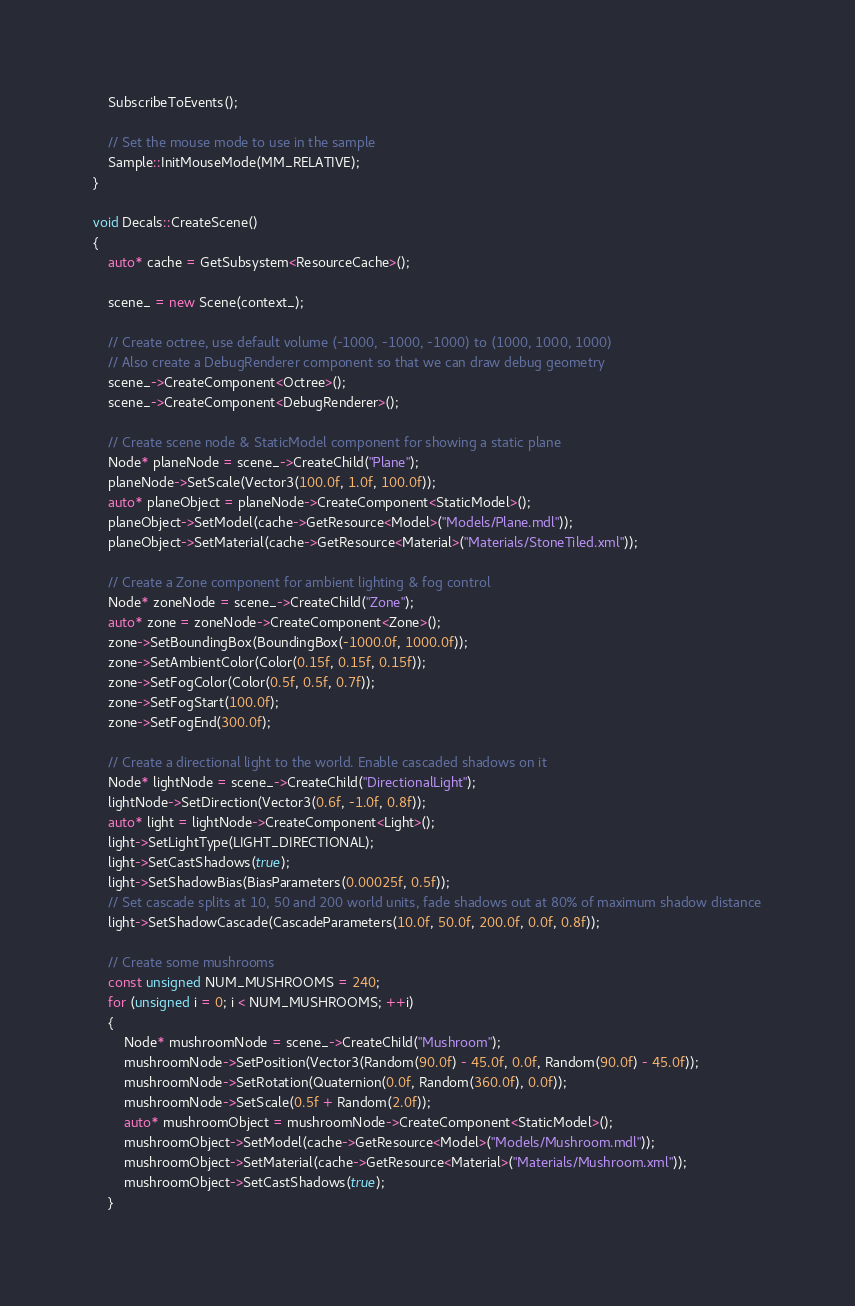Convert code to text. <code><loc_0><loc_0><loc_500><loc_500><_C++_>    SubscribeToEvents();

    // Set the mouse mode to use in the sample
    Sample::InitMouseMode(MM_RELATIVE);
}

void Decals::CreateScene()
{
    auto* cache = GetSubsystem<ResourceCache>();

    scene_ = new Scene(context_);

    // Create octree, use default volume (-1000, -1000, -1000) to (1000, 1000, 1000)
    // Also create a DebugRenderer component so that we can draw debug geometry
    scene_->CreateComponent<Octree>();
    scene_->CreateComponent<DebugRenderer>();

    // Create scene node & StaticModel component for showing a static plane
    Node* planeNode = scene_->CreateChild("Plane");
    planeNode->SetScale(Vector3(100.0f, 1.0f, 100.0f));
    auto* planeObject = planeNode->CreateComponent<StaticModel>();
    planeObject->SetModel(cache->GetResource<Model>("Models/Plane.mdl"));
    planeObject->SetMaterial(cache->GetResource<Material>("Materials/StoneTiled.xml"));

    // Create a Zone component for ambient lighting & fog control
    Node* zoneNode = scene_->CreateChild("Zone");
    auto* zone = zoneNode->CreateComponent<Zone>();
    zone->SetBoundingBox(BoundingBox(-1000.0f, 1000.0f));
    zone->SetAmbientColor(Color(0.15f, 0.15f, 0.15f));
    zone->SetFogColor(Color(0.5f, 0.5f, 0.7f));
    zone->SetFogStart(100.0f);
    zone->SetFogEnd(300.0f);

    // Create a directional light to the world. Enable cascaded shadows on it
    Node* lightNode = scene_->CreateChild("DirectionalLight");
    lightNode->SetDirection(Vector3(0.6f, -1.0f, 0.8f));
    auto* light = lightNode->CreateComponent<Light>();
    light->SetLightType(LIGHT_DIRECTIONAL);
    light->SetCastShadows(true);
    light->SetShadowBias(BiasParameters(0.00025f, 0.5f));
    // Set cascade splits at 10, 50 and 200 world units, fade shadows out at 80% of maximum shadow distance
    light->SetShadowCascade(CascadeParameters(10.0f, 50.0f, 200.0f, 0.0f, 0.8f));

    // Create some mushrooms
    const unsigned NUM_MUSHROOMS = 240;
    for (unsigned i = 0; i < NUM_MUSHROOMS; ++i)
    {
        Node* mushroomNode = scene_->CreateChild("Mushroom");
        mushroomNode->SetPosition(Vector3(Random(90.0f) - 45.0f, 0.0f, Random(90.0f) - 45.0f));
        mushroomNode->SetRotation(Quaternion(0.0f, Random(360.0f), 0.0f));
        mushroomNode->SetScale(0.5f + Random(2.0f));
        auto* mushroomObject = mushroomNode->CreateComponent<StaticModel>();
        mushroomObject->SetModel(cache->GetResource<Model>("Models/Mushroom.mdl"));
        mushroomObject->SetMaterial(cache->GetResource<Material>("Materials/Mushroom.xml"));
        mushroomObject->SetCastShadows(true);
    }
</code> 